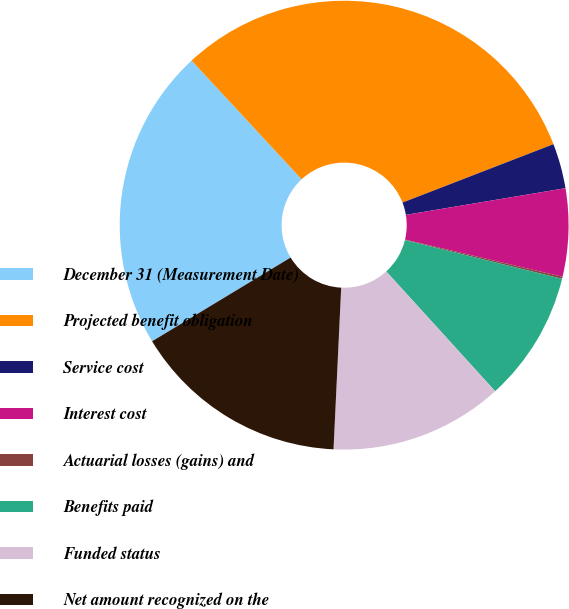Convert chart to OTSL. <chart><loc_0><loc_0><loc_500><loc_500><pie_chart><fcel>December 31 (Measurement Date)<fcel>Projected benefit obligation<fcel>Service cost<fcel>Interest cost<fcel>Actuarial losses (gains) and<fcel>Benefits paid<fcel>Funded status<fcel>Net amount recognized on the<nl><fcel>21.76%<fcel>31.02%<fcel>3.24%<fcel>6.33%<fcel>0.15%<fcel>9.41%<fcel>12.5%<fcel>15.59%<nl></chart> 